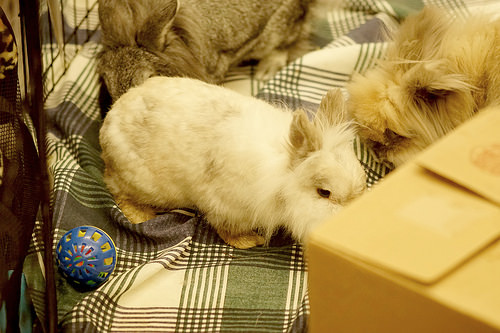<image>
Can you confirm if the toy is on the cloth? Yes. Looking at the image, I can see the toy is positioned on top of the cloth, with the cloth providing support. Where is the animal in relation to the cage? Is it in the cage? Yes. The animal is contained within or inside the cage, showing a containment relationship. Is the mouse next to the towel? No. The mouse is not positioned next to the towel. They are located in different areas of the scene. Is the rabbit in front of the box? No. The rabbit is not in front of the box. The spatial positioning shows a different relationship between these objects. 